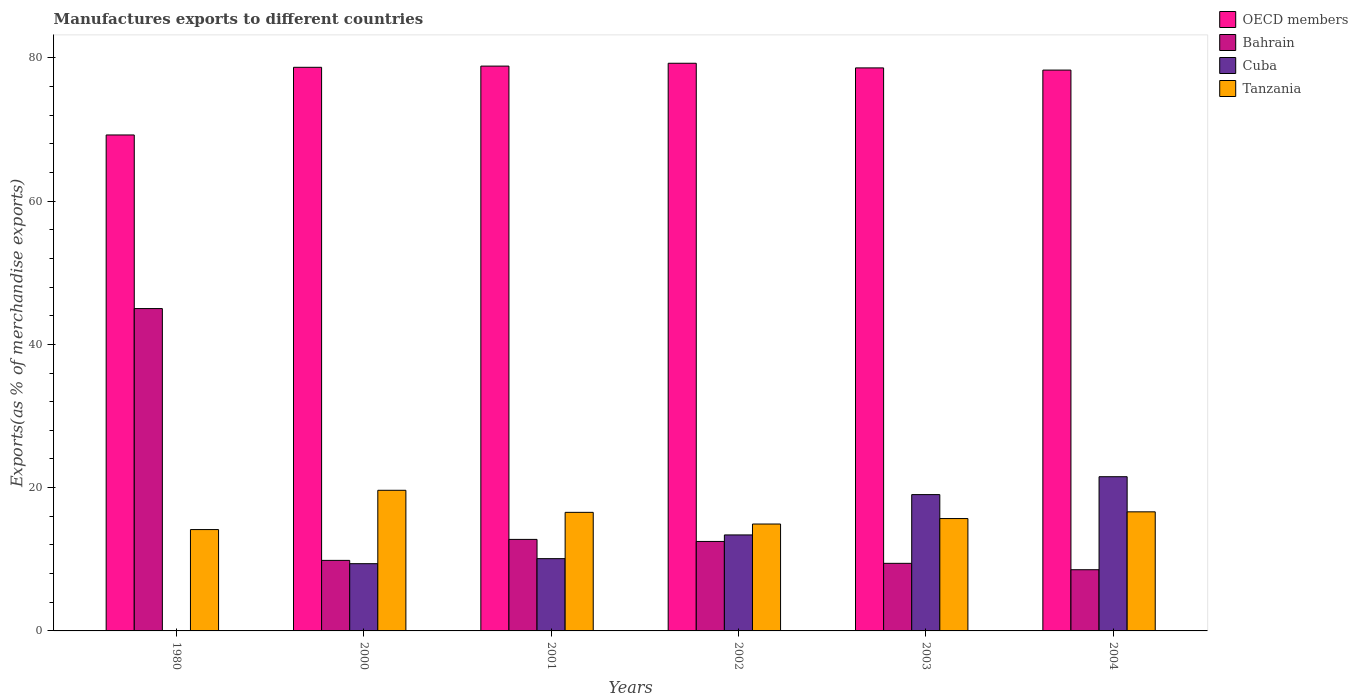How many different coloured bars are there?
Offer a very short reply. 4. How many bars are there on the 1st tick from the left?
Provide a succinct answer. 4. In how many cases, is the number of bars for a given year not equal to the number of legend labels?
Give a very brief answer. 0. What is the percentage of exports to different countries in OECD members in 2002?
Provide a short and direct response. 79.24. Across all years, what is the maximum percentage of exports to different countries in Cuba?
Provide a succinct answer. 21.53. Across all years, what is the minimum percentage of exports to different countries in OECD members?
Keep it short and to the point. 69.23. What is the total percentage of exports to different countries in Bahrain in the graph?
Your answer should be compact. 98.09. What is the difference between the percentage of exports to different countries in OECD members in 2000 and that in 2002?
Your answer should be compact. -0.57. What is the difference between the percentage of exports to different countries in OECD members in 2001 and the percentage of exports to different countries in Bahrain in 1980?
Offer a very short reply. 33.85. What is the average percentage of exports to different countries in Tanzania per year?
Give a very brief answer. 16.26. In the year 2004, what is the difference between the percentage of exports to different countries in Bahrain and percentage of exports to different countries in Cuba?
Offer a terse response. -12.99. In how many years, is the percentage of exports to different countries in OECD members greater than 68 %?
Offer a very short reply. 6. What is the ratio of the percentage of exports to different countries in OECD members in 2003 to that in 2004?
Give a very brief answer. 1. Is the difference between the percentage of exports to different countries in Bahrain in 1980 and 2004 greater than the difference between the percentage of exports to different countries in Cuba in 1980 and 2004?
Offer a very short reply. Yes. What is the difference between the highest and the second highest percentage of exports to different countries in Cuba?
Provide a succinct answer. 2.5. What is the difference between the highest and the lowest percentage of exports to different countries in Bahrain?
Keep it short and to the point. 36.46. Is it the case that in every year, the sum of the percentage of exports to different countries in Bahrain and percentage of exports to different countries in Tanzania is greater than the sum of percentage of exports to different countries in Cuba and percentage of exports to different countries in OECD members?
Give a very brief answer. Yes. What does the 1st bar from the left in 1980 represents?
Offer a very short reply. OECD members. What does the 2nd bar from the right in 2000 represents?
Offer a terse response. Cuba. Is it the case that in every year, the sum of the percentage of exports to different countries in Tanzania and percentage of exports to different countries in Cuba is greater than the percentage of exports to different countries in Bahrain?
Your answer should be compact. No. How many bars are there?
Your answer should be very brief. 24. Are all the bars in the graph horizontal?
Offer a very short reply. No. What is the difference between two consecutive major ticks on the Y-axis?
Your response must be concise. 20. Does the graph contain any zero values?
Offer a very short reply. No. Does the graph contain grids?
Provide a succinct answer. No. How many legend labels are there?
Keep it short and to the point. 4. What is the title of the graph?
Your answer should be very brief. Manufactures exports to different countries. What is the label or title of the Y-axis?
Keep it short and to the point. Exports(as % of merchandise exports). What is the Exports(as % of merchandise exports) of OECD members in 1980?
Offer a terse response. 69.23. What is the Exports(as % of merchandise exports) of Bahrain in 1980?
Provide a succinct answer. 45. What is the Exports(as % of merchandise exports) in Cuba in 1980?
Your answer should be very brief. 0.03. What is the Exports(as % of merchandise exports) of Tanzania in 1980?
Make the answer very short. 14.15. What is the Exports(as % of merchandise exports) of OECD members in 2000?
Your answer should be compact. 78.68. What is the Exports(as % of merchandise exports) of Bahrain in 2000?
Your answer should be very brief. 9.85. What is the Exports(as % of merchandise exports) of Cuba in 2000?
Offer a terse response. 9.39. What is the Exports(as % of merchandise exports) in Tanzania in 2000?
Offer a terse response. 19.63. What is the Exports(as % of merchandise exports) of OECD members in 2001?
Provide a succinct answer. 78.85. What is the Exports(as % of merchandise exports) in Bahrain in 2001?
Your response must be concise. 12.78. What is the Exports(as % of merchandise exports) in Cuba in 2001?
Your answer should be compact. 10.09. What is the Exports(as % of merchandise exports) of Tanzania in 2001?
Offer a terse response. 16.55. What is the Exports(as % of merchandise exports) of OECD members in 2002?
Give a very brief answer. 79.24. What is the Exports(as % of merchandise exports) in Bahrain in 2002?
Offer a very short reply. 12.49. What is the Exports(as % of merchandise exports) in Cuba in 2002?
Keep it short and to the point. 13.4. What is the Exports(as % of merchandise exports) of Tanzania in 2002?
Give a very brief answer. 14.92. What is the Exports(as % of merchandise exports) of OECD members in 2003?
Make the answer very short. 78.6. What is the Exports(as % of merchandise exports) of Bahrain in 2003?
Provide a succinct answer. 9.44. What is the Exports(as % of merchandise exports) in Cuba in 2003?
Offer a very short reply. 19.03. What is the Exports(as % of merchandise exports) of Tanzania in 2003?
Give a very brief answer. 15.69. What is the Exports(as % of merchandise exports) of OECD members in 2004?
Keep it short and to the point. 78.29. What is the Exports(as % of merchandise exports) of Bahrain in 2004?
Offer a terse response. 8.54. What is the Exports(as % of merchandise exports) in Cuba in 2004?
Your answer should be compact. 21.53. What is the Exports(as % of merchandise exports) of Tanzania in 2004?
Ensure brevity in your answer.  16.62. Across all years, what is the maximum Exports(as % of merchandise exports) in OECD members?
Keep it short and to the point. 79.24. Across all years, what is the maximum Exports(as % of merchandise exports) in Bahrain?
Offer a terse response. 45. Across all years, what is the maximum Exports(as % of merchandise exports) of Cuba?
Ensure brevity in your answer.  21.53. Across all years, what is the maximum Exports(as % of merchandise exports) of Tanzania?
Offer a terse response. 19.63. Across all years, what is the minimum Exports(as % of merchandise exports) in OECD members?
Keep it short and to the point. 69.23. Across all years, what is the minimum Exports(as % of merchandise exports) in Bahrain?
Provide a short and direct response. 8.54. Across all years, what is the minimum Exports(as % of merchandise exports) of Cuba?
Your answer should be very brief. 0.03. Across all years, what is the minimum Exports(as % of merchandise exports) of Tanzania?
Make the answer very short. 14.15. What is the total Exports(as % of merchandise exports) in OECD members in the graph?
Ensure brevity in your answer.  462.89. What is the total Exports(as % of merchandise exports) in Bahrain in the graph?
Offer a very short reply. 98.09. What is the total Exports(as % of merchandise exports) of Cuba in the graph?
Provide a succinct answer. 73.47. What is the total Exports(as % of merchandise exports) of Tanzania in the graph?
Make the answer very short. 97.56. What is the difference between the Exports(as % of merchandise exports) of OECD members in 1980 and that in 2000?
Offer a terse response. -9.45. What is the difference between the Exports(as % of merchandise exports) in Bahrain in 1980 and that in 2000?
Ensure brevity in your answer.  35.15. What is the difference between the Exports(as % of merchandise exports) in Cuba in 1980 and that in 2000?
Offer a terse response. -9.35. What is the difference between the Exports(as % of merchandise exports) of Tanzania in 1980 and that in 2000?
Give a very brief answer. -5.48. What is the difference between the Exports(as % of merchandise exports) of OECD members in 1980 and that in 2001?
Ensure brevity in your answer.  -9.61. What is the difference between the Exports(as % of merchandise exports) of Bahrain in 1980 and that in 2001?
Offer a very short reply. 32.22. What is the difference between the Exports(as % of merchandise exports) of Cuba in 1980 and that in 2001?
Your response must be concise. -10.06. What is the difference between the Exports(as % of merchandise exports) of Tanzania in 1980 and that in 2001?
Offer a very short reply. -2.4. What is the difference between the Exports(as % of merchandise exports) of OECD members in 1980 and that in 2002?
Make the answer very short. -10.01. What is the difference between the Exports(as % of merchandise exports) of Bahrain in 1980 and that in 2002?
Offer a very short reply. 32.51. What is the difference between the Exports(as % of merchandise exports) in Cuba in 1980 and that in 2002?
Give a very brief answer. -13.37. What is the difference between the Exports(as % of merchandise exports) in Tanzania in 1980 and that in 2002?
Make the answer very short. -0.77. What is the difference between the Exports(as % of merchandise exports) of OECD members in 1980 and that in 2003?
Ensure brevity in your answer.  -9.36. What is the difference between the Exports(as % of merchandise exports) in Bahrain in 1980 and that in 2003?
Your response must be concise. 35.56. What is the difference between the Exports(as % of merchandise exports) of Cuba in 1980 and that in 2003?
Provide a succinct answer. -19. What is the difference between the Exports(as % of merchandise exports) of Tanzania in 1980 and that in 2003?
Your response must be concise. -1.54. What is the difference between the Exports(as % of merchandise exports) of OECD members in 1980 and that in 2004?
Your response must be concise. -9.06. What is the difference between the Exports(as % of merchandise exports) in Bahrain in 1980 and that in 2004?
Your response must be concise. 36.46. What is the difference between the Exports(as % of merchandise exports) of Cuba in 1980 and that in 2004?
Your answer should be very brief. -21.5. What is the difference between the Exports(as % of merchandise exports) in Tanzania in 1980 and that in 2004?
Make the answer very short. -2.47. What is the difference between the Exports(as % of merchandise exports) in OECD members in 2000 and that in 2001?
Your answer should be very brief. -0.17. What is the difference between the Exports(as % of merchandise exports) in Bahrain in 2000 and that in 2001?
Your answer should be compact. -2.93. What is the difference between the Exports(as % of merchandise exports) in Cuba in 2000 and that in 2001?
Your answer should be compact. -0.7. What is the difference between the Exports(as % of merchandise exports) in Tanzania in 2000 and that in 2001?
Keep it short and to the point. 3.08. What is the difference between the Exports(as % of merchandise exports) in OECD members in 2000 and that in 2002?
Give a very brief answer. -0.57. What is the difference between the Exports(as % of merchandise exports) of Bahrain in 2000 and that in 2002?
Offer a very short reply. -2.64. What is the difference between the Exports(as % of merchandise exports) of Cuba in 2000 and that in 2002?
Your answer should be very brief. -4.01. What is the difference between the Exports(as % of merchandise exports) in Tanzania in 2000 and that in 2002?
Offer a very short reply. 4.71. What is the difference between the Exports(as % of merchandise exports) of OECD members in 2000 and that in 2003?
Provide a short and direct response. 0.08. What is the difference between the Exports(as % of merchandise exports) in Bahrain in 2000 and that in 2003?
Ensure brevity in your answer.  0.41. What is the difference between the Exports(as % of merchandise exports) of Cuba in 2000 and that in 2003?
Offer a very short reply. -9.64. What is the difference between the Exports(as % of merchandise exports) of Tanzania in 2000 and that in 2003?
Make the answer very short. 3.95. What is the difference between the Exports(as % of merchandise exports) of OECD members in 2000 and that in 2004?
Provide a succinct answer. 0.39. What is the difference between the Exports(as % of merchandise exports) in Bahrain in 2000 and that in 2004?
Keep it short and to the point. 1.3. What is the difference between the Exports(as % of merchandise exports) in Cuba in 2000 and that in 2004?
Provide a succinct answer. -12.14. What is the difference between the Exports(as % of merchandise exports) in Tanzania in 2000 and that in 2004?
Your answer should be very brief. 3.01. What is the difference between the Exports(as % of merchandise exports) in OECD members in 2001 and that in 2002?
Give a very brief answer. -0.4. What is the difference between the Exports(as % of merchandise exports) of Bahrain in 2001 and that in 2002?
Offer a terse response. 0.29. What is the difference between the Exports(as % of merchandise exports) in Cuba in 2001 and that in 2002?
Offer a terse response. -3.31. What is the difference between the Exports(as % of merchandise exports) of Tanzania in 2001 and that in 2002?
Offer a very short reply. 1.63. What is the difference between the Exports(as % of merchandise exports) in OECD members in 2001 and that in 2003?
Keep it short and to the point. 0.25. What is the difference between the Exports(as % of merchandise exports) of Bahrain in 2001 and that in 2003?
Provide a succinct answer. 3.34. What is the difference between the Exports(as % of merchandise exports) of Cuba in 2001 and that in 2003?
Keep it short and to the point. -8.94. What is the difference between the Exports(as % of merchandise exports) of Tanzania in 2001 and that in 2003?
Provide a short and direct response. 0.87. What is the difference between the Exports(as % of merchandise exports) of OECD members in 2001 and that in 2004?
Ensure brevity in your answer.  0.56. What is the difference between the Exports(as % of merchandise exports) in Bahrain in 2001 and that in 2004?
Offer a terse response. 4.23. What is the difference between the Exports(as % of merchandise exports) of Cuba in 2001 and that in 2004?
Offer a terse response. -11.44. What is the difference between the Exports(as % of merchandise exports) in Tanzania in 2001 and that in 2004?
Your answer should be very brief. -0.07. What is the difference between the Exports(as % of merchandise exports) of OECD members in 2002 and that in 2003?
Ensure brevity in your answer.  0.65. What is the difference between the Exports(as % of merchandise exports) in Bahrain in 2002 and that in 2003?
Your response must be concise. 3.05. What is the difference between the Exports(as % of merchandise exports) of Cuba in 2002 and that in 2003?
Offer a terse response. -5.63. What is the difference between the Exports(as % of merchandise exports) in Tanzania in 2002 and that in 2003?
Keep it short and to the point. -0.76. What is the difference between the Exports(as % of merchandise exports) of OECD members in 2002 and that in 2004?
Ensure brevity in your answer.  0.95. What is the difference between the Exports(as % of merchandise exports) in Bahrain in 2002 and that in 2004?
Provide a short and direct response. 3.95. What is the difference between the Exports(as % of merchandise exports) in Cuba in 2002 and that in 2004?
Keep it short and to the point. -8.13. What is the difference between the Exports(as % of merchandise exports) in Tanzania in 2002 and that in 2004?
Offer a very short reply. -1.7. What is the difference between the Exports(as % of merchandise exports) in OECD members in 2003 and that in 2004?
Your response must be concise. 0.31. What is the difference between the Exports(as % of merchandise exports) in Bahrain in 2003 and that in 2004?
Provide a succinct answer. 0.89. What is the difference between the Exports(as % of merchandise exports) of Cuba in 2003 and that in 2004?
Give a very brief answer. -2.5. What is the difference between the Exports(as % of merchandise exports) in Tanzania in 2003 and that in 2004?
Provide a succinct answer. -0.94. What is the difference between the Exports(as % of merchandise exports) of OECD members in 1980 and the Exports(as % of merchandise exports) of Bahrain in 2000?
Make the answer very short. 59.39. What is the difference between the Exports(as % of merchandise exports) of OECD members in 1980 and the Exports(as % of merchandise exports) of Cuba in 2000?
Your answer should be very brief. 59.85. What is the difference between the Exports(as % of merchandise exports) in OECD members in 1980 and the Exports(as % of merchandise exports) in Tanzania in 2000?
Provide a succinct answer. 49.6. What is the difference between the Exports(as % of merchandise exports) of Bahrain in 1980 and the Exports(as % of merchandise exports) of Cuba in 2000?
Ensure brevity in your answer.  35.61. What is the difference between the Exports(as % of merchandise exports) in Bahrain in 1980 and the Exports(as % of merchandise exports) in Tanzania in 2000?
Your answer should be compact. 25.37. What is the difference between the Exports(as % of merchandise exports) of Cuba in 1980 and the Exports(as % of merchandise exports) of Tanzania in 2000?
Keep it short and to the point. -19.6. What is the difference between the Exports(as % of merchandise exports) in OECD members in 1980 and the Exports(as % of merchandise exports) in Bahrain in 2001?
Ensure brevity in your answer.  56.46. What is the difference between the Exports(as % of merchandise exports) of OECD members in 1980 and the Exports(as % of merchandise exports) of Cuba in 2001?
Offer a very short reply. 59.14. What is the difference between the Exports(as % of merchandise exports) of OECD members in 1980 and the Exports(as % of merchandise exports) of Tanzania in 2001?
Ensure brevity in your answer.  52.68. What is the difference between the Exports(as % of merchandise exports) of Bahrain in 1980 and the Exports(as % of merchandise exports) of Cuba in 2001?
Provide a short and direct response. 34.91. What is the difference between the Exports(as % of merchandise exports) of Bahrain in 1980 and the Exports(as % of merchandise exports) of Tanzania in 2001?
Provide a succinct answer. 28.45. What is the difference between the Exports(as % of merchandise exports) in Cuba in 1980 and the Exports(as % of merchandise exports) in Tanzania in 2001?
Your response must be concise. -16.52. What is the difference between the Exports(as % of merchandise exports) in OECD members in 1980 and the Exports(as % of merchandise exports) in Bahrain in 2002?
Ensure brevity in your answer.  56.74. What is the difference between the Exports(as % of merchandise exports) of OECD members in 1980 and the Exports(as % of merchandise exports) of Cuba in 2002?
Provide a succinct answer. 55.83. What is the difference between the Exports(as % of merchandise exports) of OECD members in 1980 and the Exports(as % of merchandise exports) of Tanzania in 2002?
Your response must be concise. 54.31. What is the difference between the Exports(as % of merchandise exports) in Bahrain in 1980 and the Exports(as % of merchandise exports) in Cuba in 2002?
Ensure brevity in your answer.  31.6. What is the difference between the Exports(as % of merchandise exports) in Bahrain in 1980 and the Exports(as % of merchandise exports) in Tanzania in 2002?
Provide a succinct answer. 30.08. What is the difference between the Exports(as % of merchandise exports) of Cuba in 1980 and the Exports(as % of merchandise exports) of Tanzania in 2002?
Provide a succinct answer. -14.89. What is the difference between the Exports(as % of merchandise exports) of OECD members in 1980 and the Exports(as % of merchandise exports) of Bahrain in 2003?
Ensure brevity in your answer.  59.8. What is the difference between the Exports(as % of merchandise exports) of OECD members in 1980 and the Exports(as % of merchandise exports) of Cuba in 2003?
Give a very brief answer. 50.2. What is the difference between the Exports(as % of merchandise exports) in OECD members in 1980 and the Exports(as % of merchandise exports) in Tanzania in 2003?
Keep it short and to the point. 53.55. What is the difference between the Exports(as % of merchandise exports) of Bahrain in 1980 and the Exports(as % of merchandise exports) of Cuba in 2003?
Offer a very short reply. 25.97. What is the difference between the Exports(as % of merchandise exports) of Bahrain in 1980 and the Exports(as % of merchandise exports) of Tanzania in 2003?
Offer a terse response. 29.31. What is the difference between the Exports(as % of merchandise exports) in Cuba in 1980 and the Exports(as % of merchandise exports) in Tanzania in 2003?
Your answer should be compact. -15.65. What is the difference between the Exports(as % of merchandise exports) in OECD members in 1980 and the Exports(as % of merchandise exports) in Bahrain in 2004?
Your answer should be very brief. 60.69. What is the difference between the Exports(as % of merchandise exports) in OECD members in 1980 and the Exports(as % of merchandise exports) in Cuba in 2004?
Keep it short and to the point. 47.7. What is the difference between the Exports(as % of merchandise exports) in OECD members in 1980 and the Exports(as % of merchandise exports) in Tanzania in 2004?
Make the answer very short. 52.61. What is the difference between the Exports(as % of merchandise exports) of Bahrain in 1980 and the Exports(as % of merchandise exports) of Cuba in 2004?
Offer a very short reply. 23.47. What is the difference between the Exports(as % of merchandise exports) of Bahrain in 1980 and the Exports(as % of merchandise exports) of Tanzania in 2004?
Ensure brevity in your answer.  28.38. What is the difference between the Exports(as % of merchandise exports) of Cuba in 1980 and the Exports(as % of merchandise exports) of Tanzania in 2004?
Make the answer very short. -16.59. What is the difference between the Exports(as % of merchandise exports) of OECD members in 2000 and the Exports(as % of merchandise exports) of Bahrain in 2001?
Ensure brevity in your answer.  65.9. What is the difference between the Exports(as % of merchandise exports) in OECD members in 2000 and the Exports(as % of merchandise exports) in Cuba in 2001?
Provide a succinct answer. 68.59. What is the difference between the Exports(as % of merchandise exports) in OECD members in 2000 and the Exports(as % of merchandise exports) in Tanzania in 2001?
Give a very brief answer. 62.13. What is the difference between the Exports(as % of merchandise exports) of Bahrain in 2000 and the Exports(as % of merchandise exports) of Cuba in 2001?
Provide a short and direct response. -0.24. What is the difference between the Exports(as % of merchandise exports) in Bahrain in 2000 and the Exports(as % of merchandise exports) in Tanzania in 2001?
Your answer should be very brief. -6.71. What is the difference between the Exports(as % of merchandise exports) in Cuba in 2000 and the Exports(as % of merchandise exports) in Tanzania in 2001?
Your response must be concise. -7.17. What is the difference between the Exports(as % of merchandise exports) of OECD members in 2000 and the Exports(as % of merchandise exports) of Bahrain in 2002?
Ensure brevity in your answer.  66.19. What is the difference between the Exports(as % of merchandise exports) in OECD members in 2000 and the Exports(as % of merchandise exports) in Cuba in 2002?
Offer a terse response. 65.28. What is the difference between the Exports(as % of merchandise exports) of OECD members in 2000 and the Exports(as % of merchandise exports) of Tanzania in 2002?
Your answer should be very brief. 63.76. What is the difference between the Exports(as % of merchandise exports) of Bahrain in 2000 and the Exports(as % of merchandise exports) of Cuba in 2002?
Offer a very short reply. -3.55. What is the difference between the Exports(as % of merchandise exports) of Bahrain in 2000 and the Exports(as % of merchandise exports) of Tanzania in 2002?
Your answer should be compact. -5.08. What is the difference between the Exports(as % of merchandise exports) of Cuba in 2000 and the Exports(as % of merchandise exports) of Tanzania in 2002?
Provide a short and direct response. -5.54. What is the difference between the Exports(as % of merchandise exports) of OECD members in 2000 and the Exports(as % of merchandise exports) of Bahrain in 2003?
Ensure brevity in your answer.  69.24. What is the difference between the Exports(as % of merchandise exports) of OECD members in 2000 and the Exports(as % of merchandise exports) of Cuba in 2003?
Offer a very short reply. 59.65. What is the difference between the Exports(as % of merchandise exports) of OECD members in 2000 and the Exports(as % of merchandise exports) of Tanzania in 2003?
Your answer should be compact. 62.99. What is the difference between the Exports(as % of merchandise exports) in Bahrain in 2000 and the Exports(as % of merchandise exports) in Cuba in 2003?
Make the answer very short. -9.18. What is the difference between the Exports(as % of merchandise exports) in Bahrain in 2000 and the Exports(as % of merchandise exports) in Tanzania in 2003?
Offer a terse response. -5.84. What is the difference between the Exports(as % of merchandise exports) of Cuba in 2000 and the Exports(as % of merchandise exports) of Tanzania in 2003?
Provide a succinct answer. -6.3. What is the difference between the Exports(as % of merchandise exports) in OECD members in 2000 and the Exports(as % of merchandise exports) in Bahrain in 2004?
Provide a short and direct response. 70.14. What is the difference between the Exports(as % of merchandise exports) of OECD members in 2000 and the Exports(as % of merchandise exports) of Cuba in 2004?
Your answer should be compact. 57.15. What is the difference between the Exports(as % of merchandise exports) of OECD members in 2000 and the Exports(as % of merchandise exports) of Tanzania in 2004?
Provide a succinct answer. 62.05. What is the difference between the Exports(as % of merchandise exports) in Bahrain in 2000 and the Exports(as % of merchandise exports) in Cuba in 2004?
Your answer should be very brief. -11.68. What is the difference between the Exports(as % of merchandise exports) in Bahrain in 2000 and the Exports(as % of merchandise exports) in Tanzania in 2004?
Make the answer very short. -6.78. What is the difference between the Exports(as % of merchandise exports) in Cuba in 2000 and the Exports(as % of merchandise exports) in Tanzania in 2004?
Your answer should be compact. -7.24. What is the difference between the Exports(as % of merchandise exports) in OECD members in 2001 and the Exports(as % of merchandise exports) in Bahrain in 2002?
Your response must be concise. 66.36. What is the difference between the Exports(as % of merchandise exports) in OECD members in 2001 and the Exports(as % of merchandise exports) in Cuba in 2002?
Provide a succinct answer. 65.45. What is the difference between the Exports(as % of merchandise exports) in OECD members in 2001 and the Exports(as % of merchandise exports) in Tanzania in 2002?
Your answer should be compact. 63.92. What is the difference between the Exports(as % of merchandise exports) in Bahrain in 2001 and the Exports(as % of merchandise exports) in Cuba in 2002?
Make the answer very short. -0.62. What is the difference between the Exports(as % of merchandise exports) in Bahrain in 2001 and the Exports(as % of merchandise exports) in Tanzania in 2002?
Your response must be concise. -2.15. What is the difference between the Exports(as % of merchandise exports) of Cuba in 2001 and the Exports(as % of merchandise exports) of Tanzania in 2002?
Your answer should be compact. -4.83. What is the difference between the Exports(as % of merchandise exports) in OECD members in 2001 and the Exports(as % of merchandise exports) in Bahrain in 2003?
Offer a terse response. 69.41. What is the difference between the Exports(as % of merchandise exports) in OECD members in 2001 and the Exports(as % of merchandise exports) in Cuba in 2003?
Offer a terse response. 59.82. What is the difference between the Exports(as % of merchandise exports) in OECD members in 2001 and the Exports(as % of merchandise exports) in Tanzania in 2003?
Make the answer very short. 63.16. What is the difference between the Exports(as % of merchandise exports) in Bahrain in 2001 and the Exports(as % of merchandise exports) in Cuba in 2003?
Provide a succinct answer. -6.25. What is the difference between the Exports(as % of merchandise exports) of Bahrain in 2001 and the Exports(as % of merchandise exports) of Tanzania in 2003?
Give a very brief answer. -2.91. What is the difference between the Exports(as % of merchandise exports) in Cuba in 2001 and the Exports(as % of merchandise exports) in Tanzania in 2003?
Your response must be concise. -5.6. What is the difference between the Exports(as % of merchandise exports) of OECD members in 2001 and the Exports(as % of merchandise exports) of Bahrain in 2004?
Offer a terse response. 70.3. What is the difference between the Exports(as % of merchandise exports) of OECD members in 2001 and the Exports(as % of merchandise exports) of Cuba in 2004?
Ensure brevity in your answer.  57.32. What is the difference between the Exports(as % of merchandise exports) of OECD members in 2001 and the Exports(as % of merchandise exports) of Tanzania in 2004?
Make the answer very short. 62.22. What is the difference between the Exports(as % of merchandise exports) in Bahrain in 2001 and the Exports(as % of merchandise exports) in Cuba in 2004?
Make the answer very short. -8.75. What is the difference between the Exports(as % of merchandise exports) in Bahrain in 2001 and the Exports(as % of merchandise exports) in Tanzania in 2004?
Give a very brief answer. -3.85. What is the difference between the Exports(as % of merchandise exports) in Cuba in 2001 and the Exports(as % of merchandise exports) in Tanzania in 2004?
Provide a succinct answer. -6.53. What is the difference between the Exports(as % of merchandise exports) of OECD members in 2002 and the Exports(as % of merchandise exports) of Bahrain in 2003?
Offer a very short reply. 69.81. What is the difference between the Exports(as % of merchandise exports) of OECD members in 2002 and the Exports(as % of merchandise exports) of Cuba in 2003?
Give a very brief answer. 60.21. What is the difference between the Exports(as % of merchandise exports) in OECD members in 2002 and the Exports(as % of merchandise exports) in Tanzania in 2003?
Provide a short and direct response. 63.56. What is the difference between the Exports(as % of merchandise exports) of Bahrain in 2002 and the Exports(as % of merchandise exports) of Cuba in 2003?
Offer a terse response. -6.54. What is the difference between the Exports(as % of merchandise exports) in Bahrain in 2002 and the Exports(as % of merchandise exports) in Tanzania in 2003?
Your answer should be compact. -3.2. What is the difference between the Exports(as % of merchandise exports) in Cuba in 2002 and the Exports(as % of merchandise exports) in Tanzania in 2003?
Your response must be concise. -2.28. What is the difference between the Exports(as % of merchandise exports) in OECD members in 2002 and the Exports(as % of merchandise exports) in Bahrain in 2004?
Offer a very short reply. 70.7. What is the difference between the Exports(as % of merchandise exports) in OECD members in 2002 and the Exports(as % of merchandise exports) in Cuba in 2004?
Your response must be concise. 57.72. What is the difference between the Exports(as % of merchandise exports) in OECD members in 2002 and the Exports(as % of merchandise exports) in Tanzania in 2004?
Give a very brief answer. 62.62. What is the difference between the Exports(as % of merchandise exports) of Bahrain in 2002 and the Exports(as % of merchandise exports) of Cuba in 2004?
Offer a terse response. -9.04. What is the difference between the Exports(as % of merchandise exports) in Bahrain in 2002 and the Exports(as % of merchandise exports) in Tanzania in 2004?
Keep it short and to the point. -4.13. What is the difference between the Exports(as % of merchandise exports) in Cuba in 2002 and the Exports(as % of merchandise exports) in Tanzania in 2004?
Ensure brevity in your answer.  -3.22. What is the difference between the Exports(as % of merchandise exports) in OECD members in 2003 and the Exports(as % of merchandise exports) in Bahrain in 2004?
Offer a terse response. 70.05. What is the difference between the Exports(as % of merchandise exports) of OECD members in 2003 and the Exports(as % of merchandise exports) of Cuba in 2004?
Keep it short and to the point. 57.07. What is the difference between the Exports(as % of merchandise exports) of OECD members in 2003 and the Exports(as % of merchandise exports) of Tanzania in 2004?
Keep it short and to the point. 61.97. What is the difference between the Exports(as % of merchandise exports) in Bahrain in 2003 and the Exports(as % of merchandise exports) in Cuba in 2004?
Your response must be concise. -12.09. What is the difference between the Exports(as % of merchandise exports) of Bahrain in 2003 and the Exports(as % of merchandise exports) of Tanzania in 2004?
Ensure brevity in your answer.  -7.19. What is the difference between the Exports(as % of merchandise exports) of Cuba in 2003 and the Exports(as % of merchandise exports) of Tanzania in 2004?
Keep it short and to the point. 2.41. What is the average Exports(as % of merchandise exports) of OECD members per year?
Give a very brief answer. 77.15. What is the average Exports(as % of merchandise exports) in Bahrain per year?
Make the answer very short. 16.35. What is the average Exports(as % of merchandise exports) of Cuba per year?
Make the answer very short. 12.24. What is the average Exports(as % of merchandise exports) in Tanzania per year?
Your response must be concise. 16.26. In the year 1980, what is the difference between the Exports(as % of merchandise exports) of OECD members and Exports(as % of merchandise exports) of Bahrain?
Your answer should be very brief. 24.23. In the year 1980, what is the difference between the Exports(as % of merchandise exports) of OECD members and Exports(as % of merchandise exports) of Cuba?
Offer a terse response. 69.2. In the year 1980, what is the difference between the Exports(as % of merchandise exports) in OECD members and Exports(as % of merchandise exports) in Tanzania?
Provide a short and direct response. 55.08. In the year 1980, what is the difference between the Exports(as % of merchandise exports) of Bahrain and Exports(as % of merchandise exports) of Cuba?
Offer a very short reply. 44.97. In the year 1980, what is the difference between the Exports(as % of merchandise exports) of Bahrain and Exports(as % of merchandise exports) of Tanzania?
Keep it short and to the point. 30.85. In the year 1980, what is the difference between the Exports(as % of merchandise exports) in Cuba and Exports(as % of merchandise exports) in Tanzania?
Ensure brevity in your answer.  -14.12. In the year 2000, what is the difference between the Exports(as % of merchandise exports) of OECD members and Exports(as % of merchandise exports) of Bahrain?
Your response must be concise. 68.83. In the year 2000, what is the difference between the Exports(as % of merchandise exports) in OECD members and Exports(as % of merchandise exports) in Cuba?
Provide a short and direct response. 69.29. In the year 2000, what is the difference between the Exports(as % of merchandise exports) of OECD members and Exports(as % of merchandise exports) of Tanzania?
Your answer should be compact. 59.05. In the year 2000, what is the difference between the Exports(as % of merchandise exports) in Bahrain and Exports(as % of merchandise exports) in Cuba?
Your answer should be very brief. 0.46. In the year 2000, what is the difference between the Exports(as % of merchandise exports) of Bahrain and Exports(as % of merchandise exports) of Tanzania?
Offer a terse response. -9.79. In the year 2000, what is the difference between the Exports(as % of merchandise exports) in Cuba and Exports(as % of merchandise exports) in Tanzania?
Provide a succinct answer. -10.25. In the year 2001, what is the difference between the Exports(as % of merchandise exports) in OECD members and Exports(as % of merchandise exports) in Bahrain?
Your response must be concise. 66.07. In the year 2001, what is the difference between the Exports(as % of merchandise exports) of OECD members and Exports(as % of merchandise exports) of Cuba?
Make the answer very short. 68.76. In the year 2001, what is the difference between the Exports(as % of merchandise exports) of OECD members and Exports(as % of merchandise exports) of Tanzania?
Your response must be concise. 62.29. In the year 2001, what is the difference between the Exports(as % of merchandise exports) in Bahrain and Exports(as % of merchandise exports) in Cuba?
Keep it short and to the point. 2.69. In the year 2001, what is the difference between the Exports(as % of merchandise exports) in Bahrain and Exports(as % of merchandise exports) in Tanzania?
Provide a succinct answer. -3.78. In the year 2001, what is the difference between the Exports(as % of merchandise exports) in Cuba and Exports(as % of merchandise exports) in Tanzania?
Provide a short and direct response. -6.46. In the year 2002, what is the difference between the Exports(as % of merchandise exports) in OECD members and Exports(as % of merchandise exports) in Bahrain?
Keep it short and to the point. 66.75. In the year 2002, what is the difference between the Exports(as % of merchandise exports) of OECD members and Exports(as % of merchandise exports) of Cuba?
Your answer should be very brief. 65.84. In the year 2002, what is the difference between the Exports(as % of merchandise exports) in OECD members and Exports(as % of merchandise exports) in Tanzania?
Your response must be concise. 64.32. In the year 2002, what is the difference between the Exports(as % of merchandise exports) of Bahrain and Exports(as % of merchandise exports) of Cuba?
Keep it short and to the point. -0.91. In the year 2002, what is the difference between the Exports(as % of merchandise exports) in Bahrain and Exports(as % of merchandise exports) in Tanzania?
Your response must be concise. -2.43. In the year 2002, what is the difference between the Exports(as % of merchandise exports) of Cuba and Exports(as % of merchandise exports) of Tanzania?
Your answer should be very brief. -1.52. In the year 2003, what is the difference between the Exports(as % of merchandise exports) in OECD members and Exports(as % of merchandise exports) in Bahrain?
Provide a succinct answer. 69.16. In the year 2003, what is the difference between the Exports(as % of merchandise exports) of OECD members and Exports(as % of merchandise exports) of Cuba?
Offer a very short reply. 59.57. In the year 2003, what is the difference between the Exports(as % of merchandise exports) of OECD members and Exports(as % of merchandise exports) of Tanzania?
Ensure brevity in your answer.  62.91. In the year 2003, what is the difference between the Exports(as % of merchandise exports) of Bahrain and Exports(as % of merchandise exports) of Cuba?
Offer a terse response. -9.59. In the year 2003, what is the difference between the Exports(as % of merchandise exports) of Bahrain and Exports(as % of merchandise exports) of Tanzania?
Offer a very short reply. -6.25. In the year 2003, what is the difference between the Exports(as % of merchandise exports) of Cuba and Exports(as % of merchandise exports) of Tanzania?
Provide a short and direct response. 3.34. In the year 2004, what is the difference between the Exports(as % of merchandise exports) in OECD members and Exports(as % of merchandise exports) in Bahrain?
Your answer should be compact. 69.75. In the year 2004, what is the difference between the Exports(as % of merchandise exports) of OECD members and Exports(as % of merchandise exports) of Cuba?
Give a very brief answer. 56.76. In the year 2004, what is the difference between the Exports(as % of merchandise exports) of OECD members and Exports(as % of merchandise exports) of Tanzania?
Make the answer very short. 61.67. In the year 2004, what is the difference between the Exports(as % of merchandise exports) in Bahrain and Exports(as % of merchandise exports) in Cuba?
Your answer should be compact. -12.99. In the year 2004, what is the difference between the Exports(as % of merchandise exports) of Bahrain and Exports(as % of merchandise exports) of Tanzania?
Your answer should be compact. -8.08. In the year 2004, what is the difference between the Exports(as % of merchandise exports) in Cuba and Exports(as % of merchandise exports) in Tanzania?
Ensure brevity in your answer.  4.9. What is the ratio of the Exports(as % of merchandise exports) of Bahrain in 1980 to that in 2000?
Your answer should be compact. 4.57. What is the ratio of the Exports(as % of merchandise exports) of Cuba in 1980 to that in 2000?
Keep it short and to the point. 0. What is the ratio of the Exports(as % of merchandise exports) of Tanzania in 1980 to that in 2000?
Make the answer very short. 0.72. What is the ratio of the Exports(as % of merchandise exports) of OECD members in 1980 to that in 2001?
Make the answer very short. 0.88. What is the ratio of the Exports(as % of merchandise exports) in Bahrain in 1980 to that in 2001?
Provide a succinct answer. 3.52. What is the ratio of the Exports(as % of merchandise exports) of Cuba in 1980 to that in 2001?
Your response must be concise. 0. What is the ratio of the Exports(as % of merchandise exports) of Tanzania in 1980 to that in 2001?
Give a very brief answer. 0.85. What is the ratio of the Exports(as % of merchandise exports) in OECD members in 1980 to that in 2002?
Keep it short and to the point. 0.87. What is the ratio of the Exports(as % of merchandise exports) in Bahrain in 1980 to that in 2002?
Make the answer very short. 3.6. What is the ratio of the Exports(as % of merchandise exports) of Cuba in 1980 to that in 2002?
Make the answer very short. 0. What is the ratio of the Exports(as % of merchandise exports) in Tanzania in 1980 to that in 2002?
Your response must be concise. 0.95. What is the ratio of the Exports(as % of merchandise exports) of OECD members in 1980 to that in 2003?
Give a very brief answer. 0.88. What is the ratio of the Exports(as % of merchandise exports) of Bahrain in 1980 to that in 2003?
Keep it short and to the point. 4.77. What is the ratio of the Exports(as % of merchandise exports) of Cuba in 1980 to that in 2003?
Your response must be concise. 0. What is the ratio of the Exports(as % of merchandise exports) of Tanzania in 1980 to that in 2003?
Your response must be concise. 0.9. What is the ratio of the Exports(as % of merchandise exports) of OECD members in 1980 to that in 2004?
Give a very brief answer. 0.88. What is the ratio of the Exports(as % of merchandise exports) in Bahrain in 1980 to that in 2004?
Give a very brief answer. 5.27. What is the ratio of the Exports(as % of merchandise exports) of Cuba in 1980 to that in 2004?
Your answer should be compact. 0. What is the ratio of the Exports(as % of merchandise exports) of Tanzania in 1980 to that in 2004?
Offer a very short reply. 0.85. What is the ratio of the Exports(as % of merchandise exports) of OECD members in 2000 to that in 2001?
Your answer should be compact. 1. What is the ratio of the Exports(as % of merchandise exports) of Bahrain in 2000 to that in 2001?
Offer a terse response. 0.77. What is the ratio of the Exports(as % of merchandise exports) of Cuba in 2000 to that in 2001?
Provide a short and direct response. 0.93. What is the ratio of the Exports(as % of merchandise exports) in Tanzania in 2000 to that in 2001?
Offer a very short reply. 1.19. What is the ratio of the Exports(as % of merchandise exports) in OECD members in 2000 to that in 2002?
Make the answer very short. 0.99. What is the ratio of the Exports(as % of merchandise exports) of Bahrain in 2000 to that in 2002?
Offer a very short reply. 0.79. What is the ratio of the Exports(as % of merchandise exports) in Cuba in 2000 to that in 2002?
Your answer should be compact. 0.7. What is the ratio of the Exports(as % of merchandise exports) in Tanzania in 2000 to that in 2002?
Your response must be concise. 1.32. What is the ratio of the Exports(as % of merchandise exports) of Bahrain in 2000 to that in 2003?
Offer a terse response. 1.04. What is the ratio of the Exports(as % of merchandise exports) of Cuba in 2000 to that in 2003?
Make the answer very short. 0.49. What is the ratio of the Exports(as % of merchandise exports) in Tanzania in 2000 to that in 2003?
Provide a succinct answer. 1.25. What is the ratio of the Exports(as % of merchandise exports) in OECD members in 2000 to that in 2004?
Keep it short and to the point. 1. What is the ratio of the Exports(as % of merchandise exports) in Bahrain in 2000 to that in 2004?
Provide a short and direct response. 1.15. What is the ratio of the Exports(as % of merchandise exports) of Cuba in 2000 to that in 2004?
Your answer should be very brief. 0.44. What is the ratio of the Exports(as % of merchandise exports) of Tanzania in 2000 to that in 2004?
Keep it short and to the point. 1.18. What is the ratio of the Exports(as % of merchandise exports) of OECD members in 2001 to that in 2002?
Your answer should be very brief. 0.99. What is the ratio of the Exports(as % of merchandise exports) in Bahrain in 2001 to that in 2002?
Make the answer very short. 1.02. What is the ratio of the Exports(as % of merchandise exports) in Cuba in 2001 to that in 2002?
Your answer should be compact. 0.75. What is the ratio of the Exports(as % of merchandise exports) in Tanzania in 2001 to that in 2002?
Offer a terse response. 1.11. What is the ratio of the Exports(as % of merchandise exports) of Bahrain in 2001 to that in 2003?
Keep it short and to the point. 1.35. What is the ratio of the Exports(as % of merchandise exports) of Cuba in 2001 to that in 2003?
Ensure brevity in your answer.  0.53. What is the ratio of the Exports(as % of merchandise exports) of Tanzania in 2001 to that in 2003?
Ensure brevity in your answer.  1.06. What is the ratio of the Exports(as % of merchandise exports) of OECD members in 2001 to that in 2004?
Your answer should be compact. 1.01. What is the ratio of the Exports(as % of merchandise exports) of Bahrain in 2001 to that in 2004?
Your response must be concise. 1.5. What is the ratio of the Exports(as % of merchandise exports) in Cuba in 2001 to that in 2004?
Ensure brevity in your answer.  0.47. What is the ratio of the Exports(as % of merchandise exports) of Tanzania in 2001 to that in 2004?
Ensure brevity in your answer.  1. What is the ratio of the Exports(as % of merchandise exports) in OECD members in 2002 to that in 2003?
Offer a very short reply. 1.01. What is the ratio of the Exports(as % of merchandise exports) of Bahrain in 2002 to that in 2003?
Your answer should be compact. 1.32. What is the ratio of the Exports(as % of merchandise exports) of Cuba in 2002 to that in 2003?
Your answer should be compact. 0.7. What is the ratio of the Exports(as % of merchandise exports) of Tanzania in 2002 to that in 2003?
Make the answer very short. 0.95. What is the ratio of the Exports(as % of merchandise exports) in OECD members in 2002 to that in 2004?
Give a very brief answer. 1.01. What is the ratio of the Exports(as % of merchandise exports) in Bahrain in 2002 to that in 2004?
Your answer should be very brief. 1.46. What is the ratio of the Exports(as % of merchandise exports) in Cuba in 2002 to that in 2004?
Make the answer very short. 0.62. What is the ratio of the Exports(as % of merchandise exports) of Tanzania in 2002 to that in 2004?
Keep it short and to the point. 0.9. What is the ratio of the Exports(as % of merchandise exports) in Bahrain in 2003 to that in 2004?
Provide a short and direct response. 1.1. What is the ratio of the Exports(as % of merchandise exports) in Cuba in 2003 to that in 2004?
Provide a succinct answer. 0.88. What is the ratio of the Exports(as % of merchandise exports) of Tanzania in 2003 to that in 2004?
Ensure brevity in your answer.  0.94. What is the difference between the highest and the second highest Exports(as % of merchandise exports) of OECD members?
Provide a short and direct response. 0.4. What is the difference between the highest and the second highest Exports(as % of merchandise exports) in Bahrain?
Provide a short and direct response. 32.22. What is the difference between the highest and the second highest Exports(as % of merchandise exports) in Cuba?
Make the answer very short. 2.5. What is the difference between the highest and the second highest Exports(as % of merchandise exports) of Tanzania?
Make the answer very short. 3.01. What is the difference between the highest and the lowest Exports(as % of merchandise exports) in OECD members?
Offer a terse response. 10.01. What is the difference between the highest and the lowest Exports(as % of merchandise exports) of Bahrain?
Provide a succinct answer. 36.46. What is the difference between the highest and the lowest Exports(as % of merchandise exports) in Cuba?
Ensure brevity in your answer.  21.5. What is the difference between the highest and the lowest Exports(as % of merchandise exports) of Tanzania?
Make the answer very short. 5.48. 